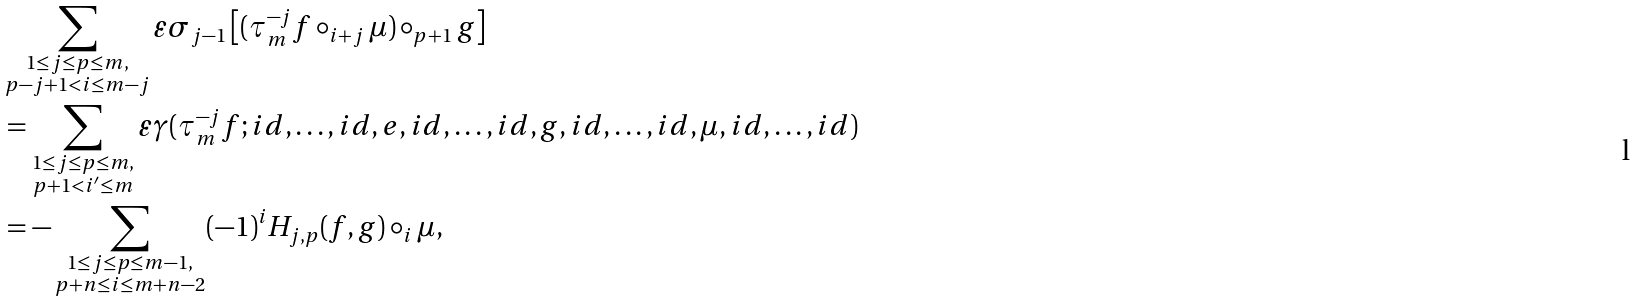<formula> <loc_0><loc_0><loc_500><loc_500>& \sum _ { \substack { 1 \leq j \leq p \leq m , \\ p - j + 1 < i \leq m - j } } \varepsilon \sigma _ { j - 1 } \left [ ( \tau ^ { - j } _ { m } f \circ _ { i + j } \mu ) \circ _ { p + 1 } g \right ] \\ & = \sum _ { \substack { 1 \leq j \leq p \leq m , \\ p + 1 < i ^ { \prime } \leq m } } \varepsilon \gamma ( \tau ^ { - j } _ { m } f ; i d , \dots , i d , e , i d , \dots , i d , g , i d , \dots , i d , \mu , i d , \dots , i d ) \\ & = - \sum _ { \substack { 1 \leq j \leq p \leq m - 1 , \\ p + n \leq i \leq m + n - 2 } } ( - 1 ) ^ { i } H _ { j , p } ( f , g ) \circ _ { i } \mu ,</formula> 